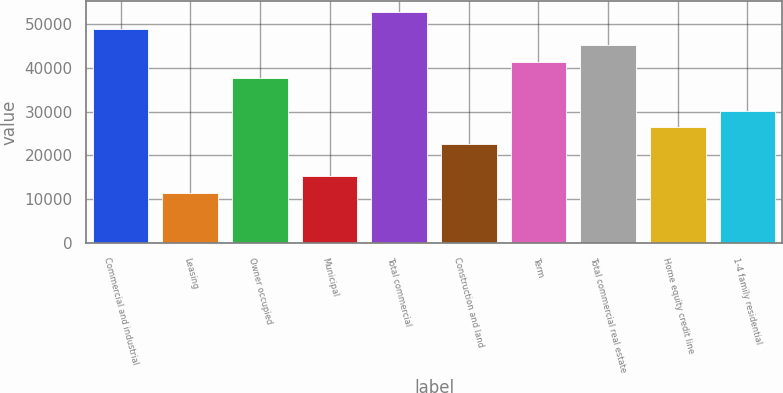Convert chart. <chart><loc_0><loc_0><loc_500><loc_500><bar_chart><fcel>Commercial and industrial<fcel>Leasing<fcel>Owner occupied<fcel>Municipal<fcel>Total commercial<fcel>Construction and land<fcel>Term<fcel>Total commercial real estate<fcel>Home equity credit line<fcel>1-4 family residential<nl><fcel>48899.7<fcel>11450.7<fcel>37665<fcel>15195.6<fcel>52644.6<fcel>22685.4<fcel>41409.9<fcel>45154.8<fcel>26430.3<fcel>30175.2<nl></chart> 